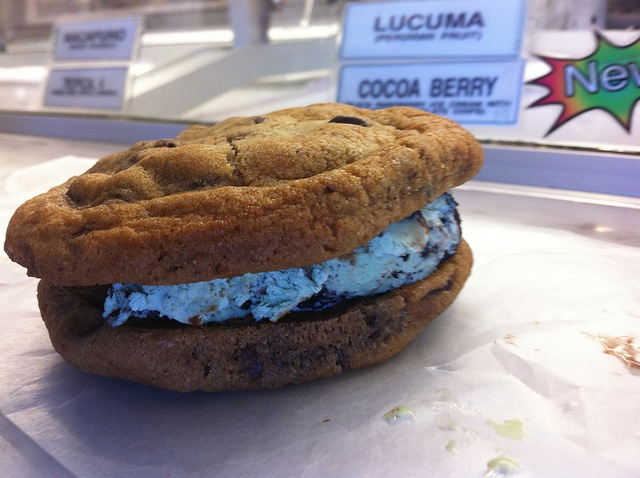Describe the objects in this image and their specific colors. I can see a sandwich in gray, maroon, and black tones in this image. 